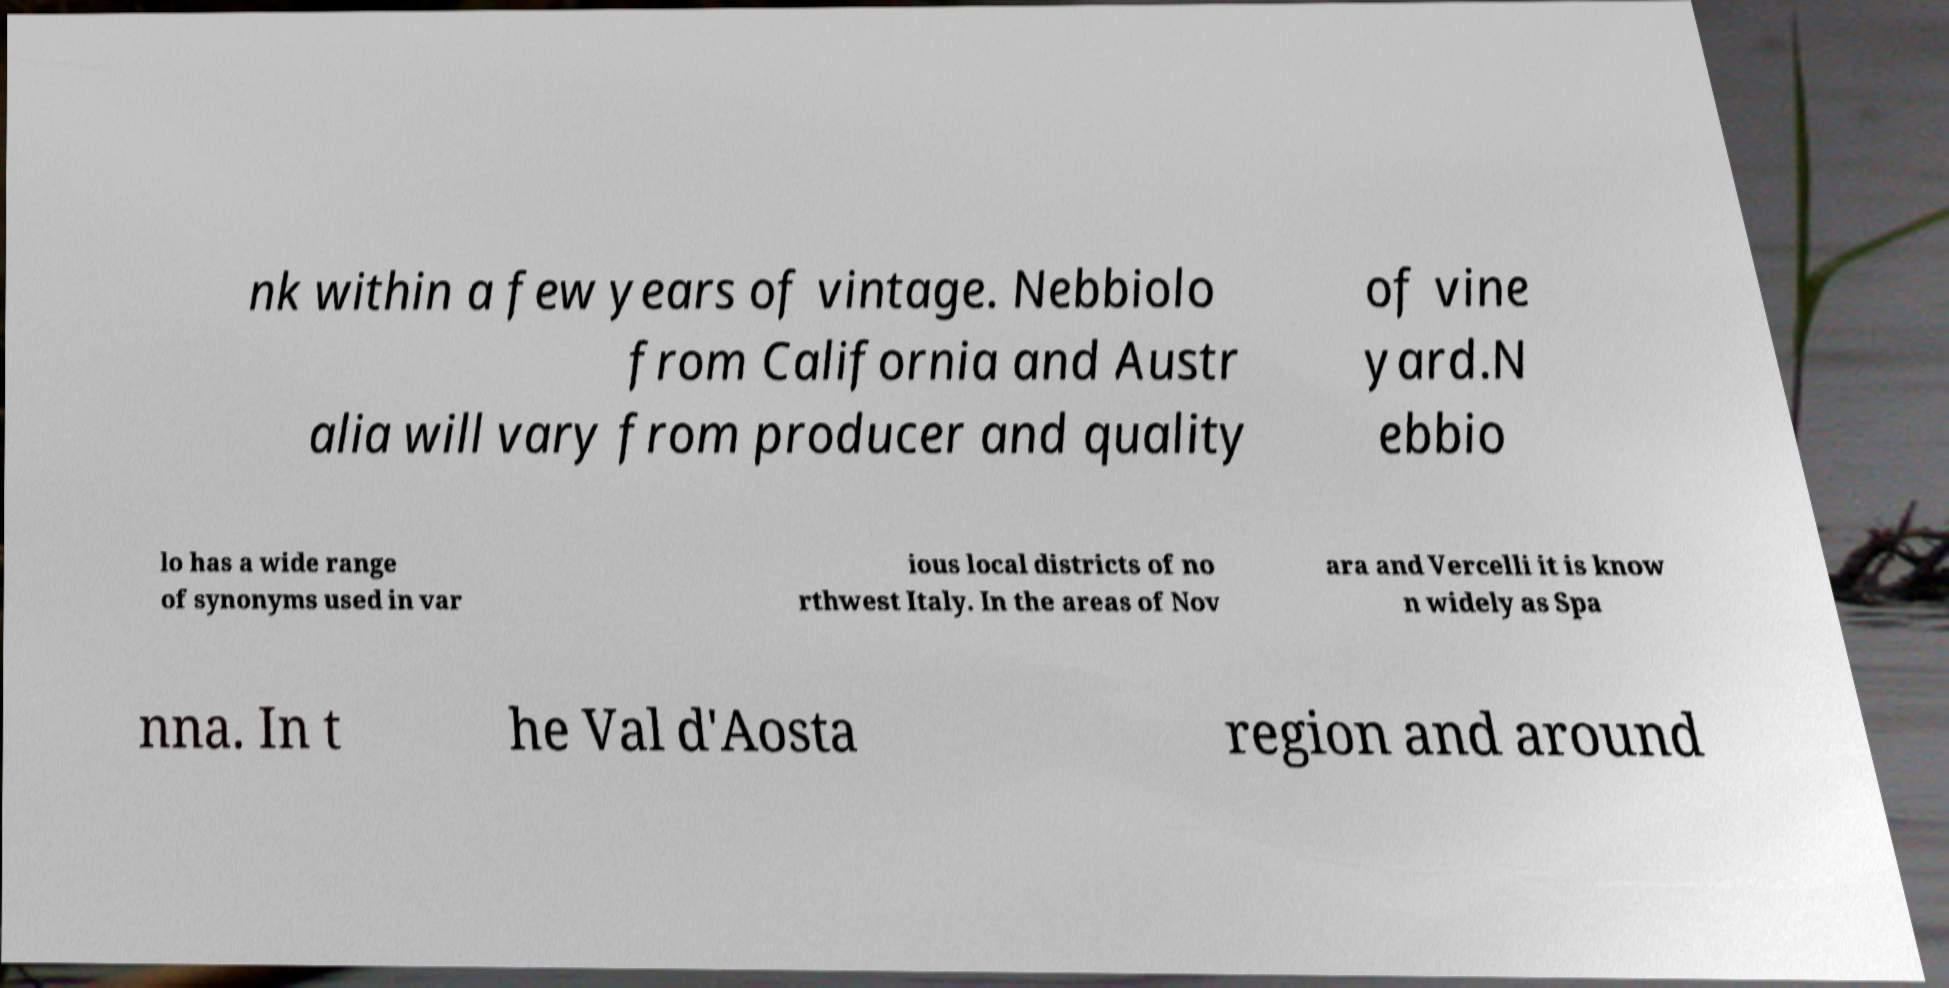Could you extract and type out the text from this image? nk within a few years of vintage. Nebbiolo from California and Austr alia will vary from producer and quality of vine yard.N ebbio lo has a wide range of synonyms used in var ious local districts of no rthwest Italy. In the areas of Nov ara and Vercelli it is know n widely as Spa nna. In t he Val d'Aosta region and around 